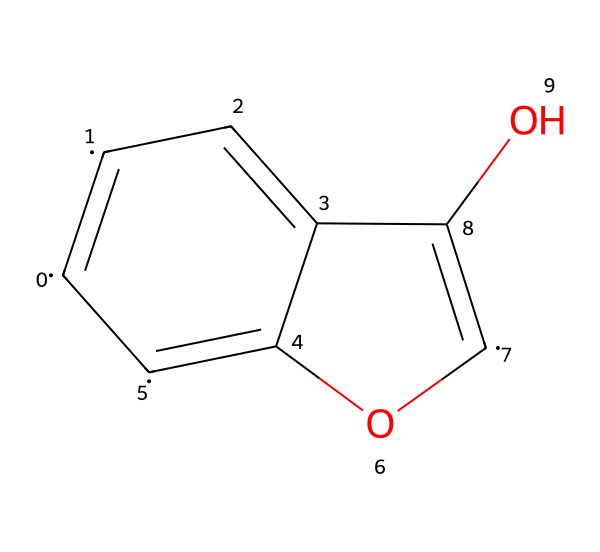What is the total number of carbon atoms in the structure? By examining the SMILES representation, we can see that there are multiple carbon atoms indicated by the letter "C." Counting each "C" gives us a total of 6 carbon atoms in the entire structure.
Answer: six How many oxygen atoms are present in this chemical? In the given SMILES structure, the oxygen atoms are represented by "O." There are two occurrences of "O" in the structure, indicating that there are two oxygen atoms.
Answer: two What type of bonding is primarily present in graphene oxide's structure? The structure exhibits double bonds (indicated by "=" in the SMILES). In graphene oxide, carbon atoms are connected by a network of covalent bonds, primarily through these double bonds, which characterize its planar structure.
Answer: covalent What functional groups can be identified in the structure of this chemical? Observing the chemical structure, the presence of hydroxyl (-OH) groups can be identified due to the oxygen atoms bonded to carbon. This reveals that the structure contains functional groups specifically related to -OH.
Answer: hydroxyl groups How does the molecular structure of graphene oxide contribute to its flexibility in display technologies? The planar arrangement of carbon atoms and the presence of hydroxyl groups provide the material with mechanical strength and flexibility. The covalent bonding allows for the creation of thin films that can bend without breaking, enhancing their application in flexible displays.
Answer: flexibility What is the primary use of graphene oxide in gadget technologies? Graphene oxide is known for its excellent electrical conductivity and mechanical properties, which make it ideal for use in flexible display technologies, such as screens and other electronic devices.
Answer: flexible displays 